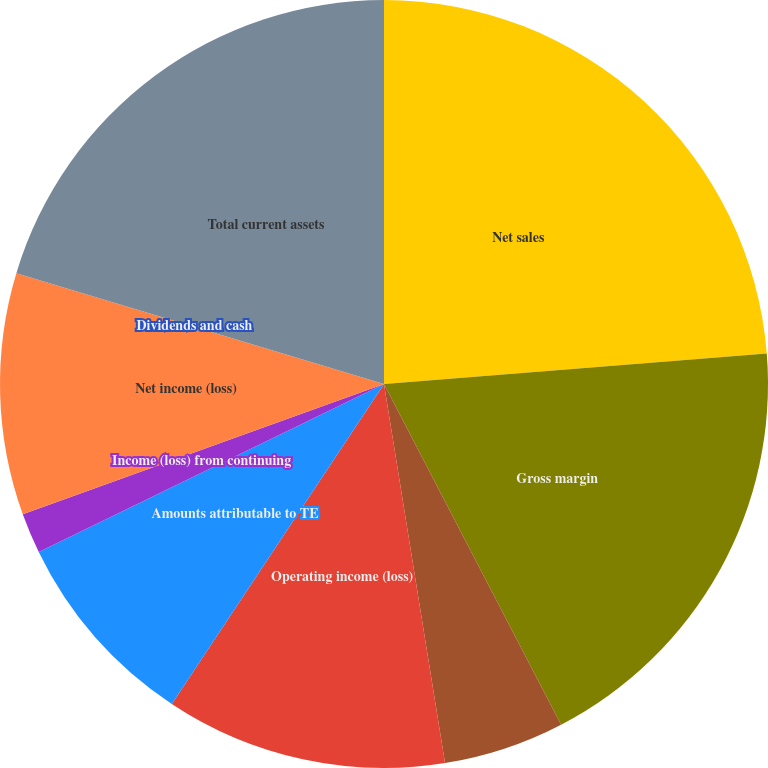Convert chart. <chart><loc_0><loc_0><loc_500><loc_500><pie_chart><fcel>Net sales<fcel>Gross margin<fcel>Restructuring and other<fcel>Operating income (loss)<fcel>Amounts attributable to TE<fcel>Income (loss) from continuing<fcel>Net income (loss)<fcel>Dividends and cash<fcel>Total current assets<nl><fcel>23.73%<fcel>18.64%<fcel>5.09%<fcel>11.86%<fcel>8.47%<fcel>1.7%<fcel>10.17%<fcel>0.0%<fcel>20.34%<nl></chart> 